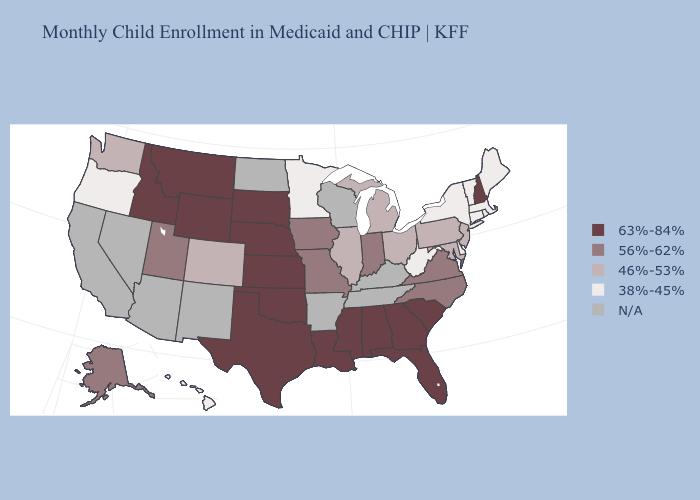What is the value of Arizona?
Give a very brief answer. N/A. Name the states that have a value in the range 63%-84%?
Give a very brief answer. Alabama, Florida, Georgia, Idaho, Kansas, Louisiana, Mississippi, Montana, Nebraska, New Hampshire, Oklahoma, South Carolina, South Dakota, Texas, Wyoming. Name the states that have a value in the range 63%-84%?
Keep it brief. Alabama, Florida, Georgia, Idaho, Kansas, Louisiana, Mississippi, Montana, Nebraska, New Hampshire, Oklahoma, South Carolina, South Dakota, Texas, Wyoming. Does Oregon have the lowest value in the West?
Concise answer only. Yes. Does South Dakota have the lowest value in the MidWest?
Be succinct. No. Name the states that have a value in the range 63%-84%?
Answer briefly. Alabama, Florida, Georgia, Idaho, Kansas, Louisiana, Mississippi, Montana, Nebraska, New Hampshire, Oklahoma, South Carolina, South Dakota, Texas, Wyoming. Which states hav the highest value in the Northeast?
Short answer required. New Hampshire. Name the states that have a value in the range 63%-84%?
Quick response, please. Alabama, Florida, Georgia, Idaho, Kansas, Louisiana, Mississippi, Montana, Nebraska, New Hampshire, Oklahoma, South Carolina, South Dakota, Texas, Wyoming. Name the states that have a value in the range 38%-45%?
Write a very short answer. Connecticut, Delaware, Hawaii, Maine, Massachusetts, Minnesota, New York, Oregon, Rhode Island, Vermont, West Virginia. What is the value of Mississippi?
Quick response, please. 63%-84%. What is the highest value in the West ?
Short answer required. 63%-84%. Name the states that have a value in the range 56%-62%?
Short answer required. Alaska, Indiana, Iowa, Missouri, North Carolina, Utah, Virginia. What is the highest value in the South ?
Write a very short answer. 63%-84%. What is the value of Nevada?
Be succinct. N/A. Name the states that have a value in the range N/A?
Concise answer only. Arizona, Arkansas, California, Kentucky, Nevada, New Mexico, North Dakota, Tennessee, Wisconsin. 